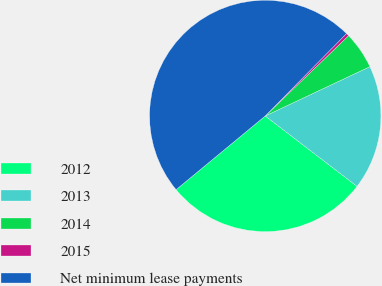<chart> <loc_0><loc_0><loc_500><loc_500><pie_chart><fcel>2012<fcel>2013<fcel>2014<fcel>2015<fcel>Net minimum lease payments<nl><fcel>28.59%<fcel>17.42%<fcel>5.2%<fcel>0.4%<fcel>48.39%<nl></chart> 